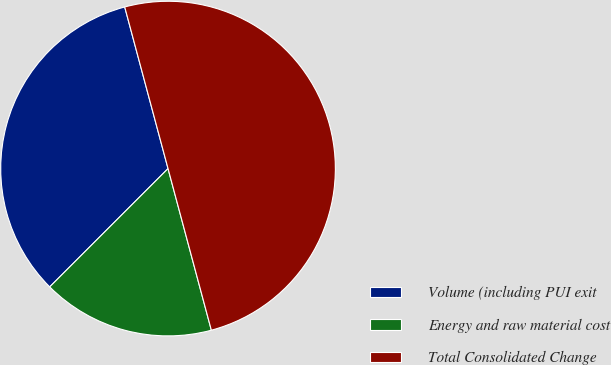<chart> <loc_0><loc_0><loc_500><loc_500><pie_chart><fcel>Volume (including PUI exit<fcel>Energy and raw material cost<fcel>Total Consolidated Change<nl><fcel>33.33%<fcel>16.67%<fcel>50.0%<nl></chart> 